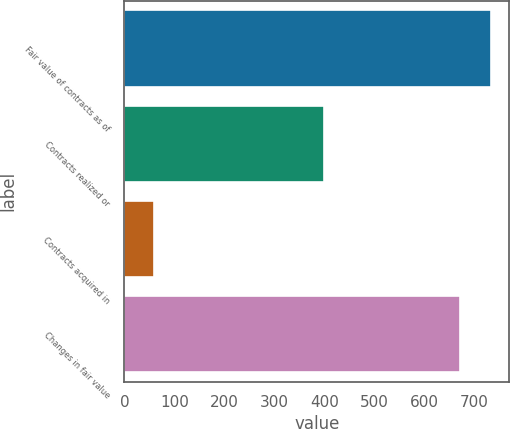Convert chart to OTSL. <chart><loc_0><loc_0><loc_500><loc_500><bar_chart><fcel>Fair value of contracts as of<fcel>Contracts realized or<fcel>Contracts acquired in<fcel>Changes in fair value<nl><fcel>733.2<fcel>399<fcel>60<fcel>672<nl></chart> 